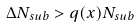Convert formula to latex. <formula><loc_0><loc_0><loc_500><loc_500>\Delta N _ { s u b } > q ( x ) N _ { s u b }</formula> 